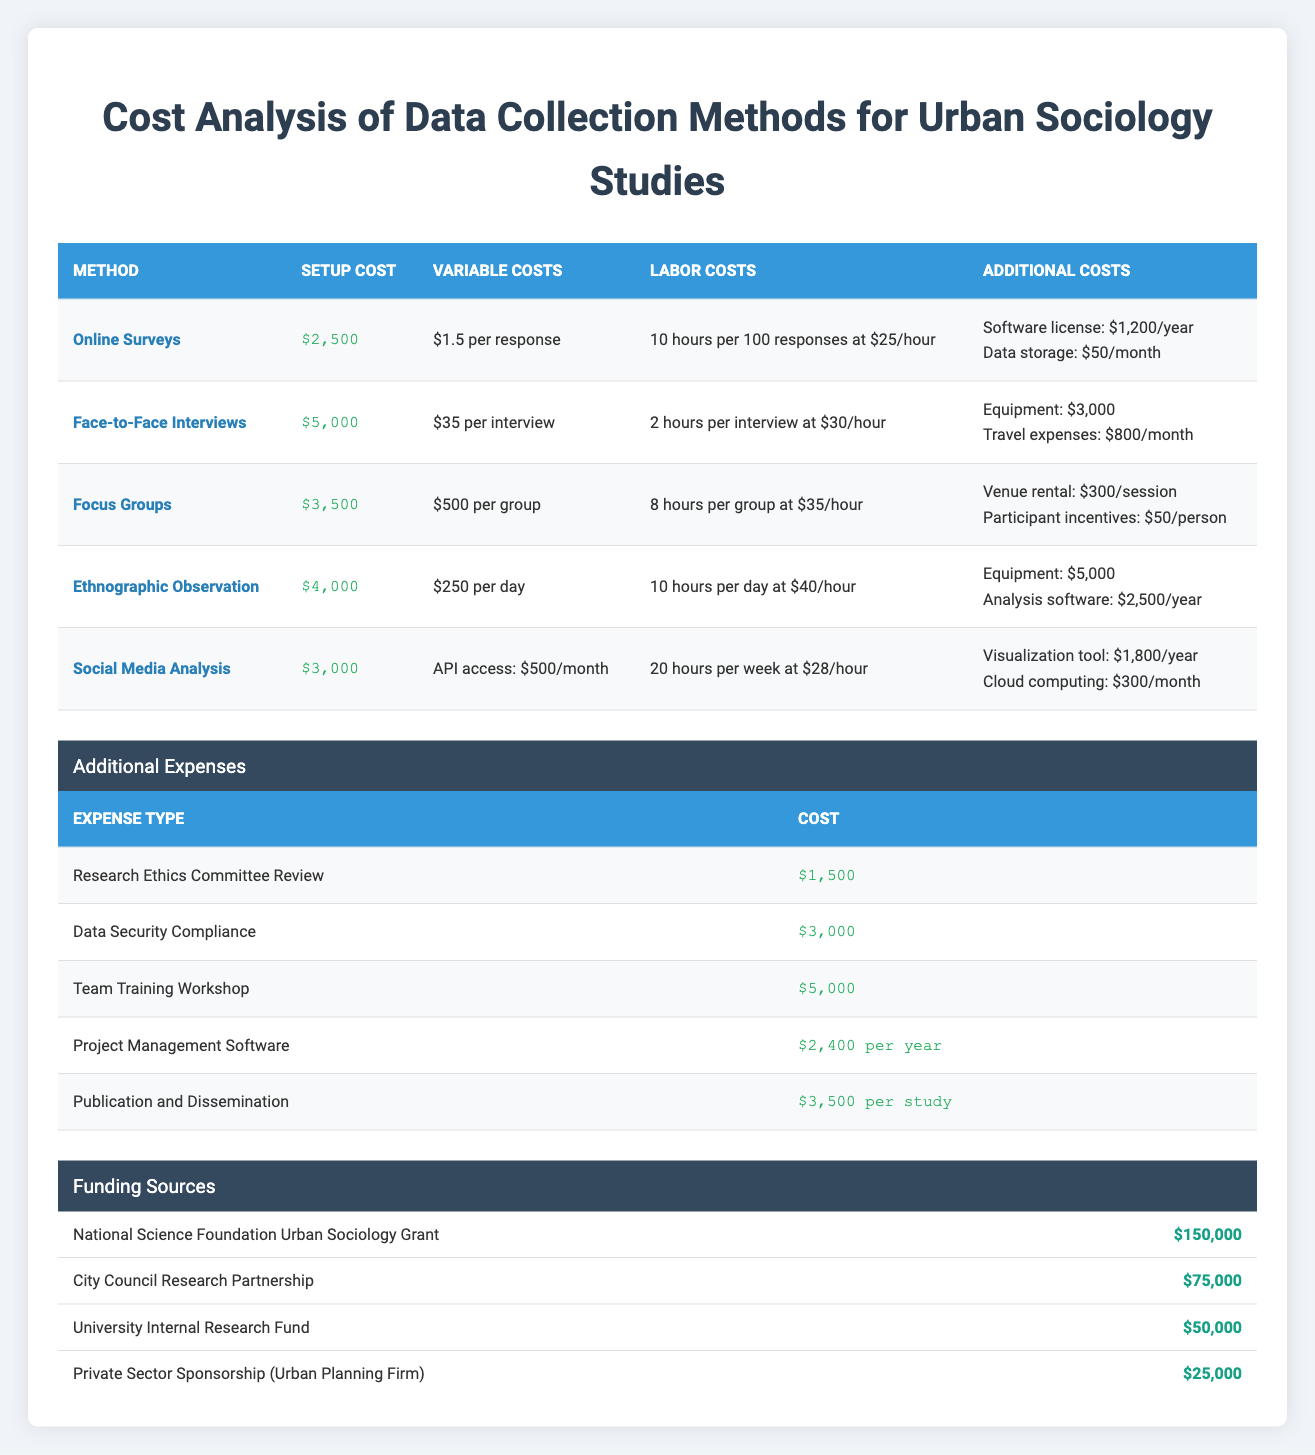What is the setup cost for Face-to-Face Interviews? The table lists the setup cost for Face-to-Face Interviews as $5,000.
Answer: $5,000 Which data collection method has the highest per-response cost? Among the methods listed, Face-to-Face Interviews have the highest variable cost at $35 per interview, which is more than the per-response cost of $1.5 for Online Surveys.
Answer: Face-to-Face Interviews What are the total additional expenses for the project? Adding the additional expenses together: $1,500 + $3,000 + $5,000 + $2,400 + $3,500 = $15,400 gives a total of $15,400 for all additional expenses.
Answer: $15,400 What is the average setup cost of the five data collection methods? The setup costs are $2,500, $5,000, $3,500, $4,000, and $3,000. Summing these ($2,500 + $5,000 + $3,500 + $4,000 + $3,000 = $18,000) and dividing by 5 gives an average of $3,600.
Answer: $3,600 Are there more funding sources than data collection methods listed? The table lists four funding sources and five data collection methods. Since 4 is less than 5, the statement is false.
Answer: No 